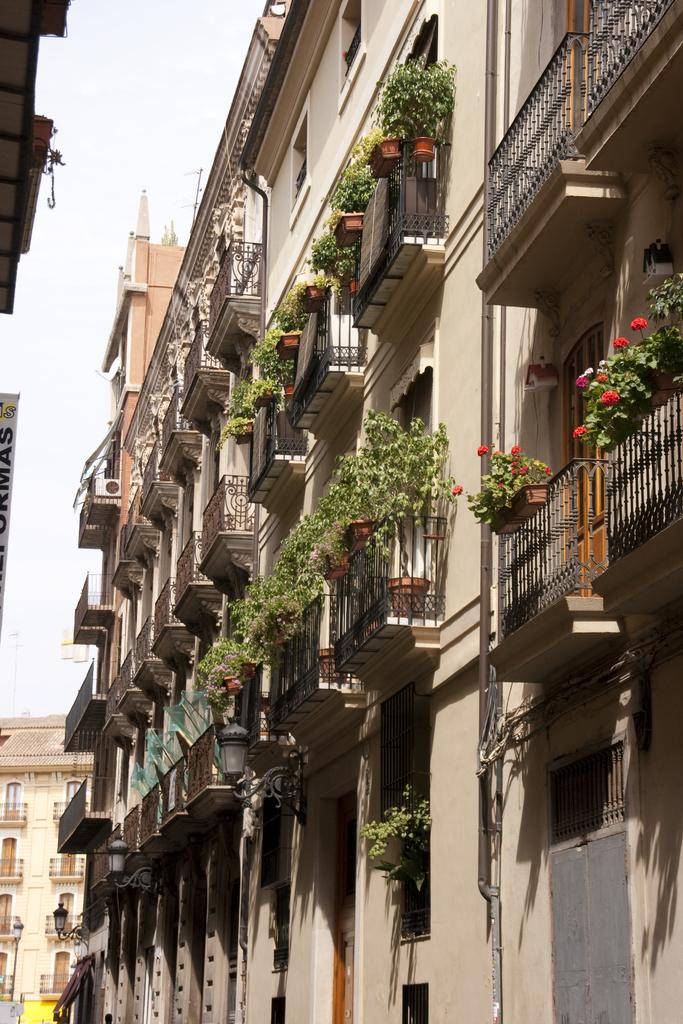What type of structures can be seen in the image? There are buildings in the image. What feature is present near the buildings? Railings are present in the image. What type of vegetation is visible in the image? House plants and flowers are visible in the image. What can be seen illuminating the area in the image? Lights are visible in the image. What is visible in the background of the image? The sky is visible in the background of the image. What word is being spelled out by the lights in the image? There is no word being spelled out by the lights in the image; they are simply illuminating the area. What type of work is being done by the flowers in the image? The flowers are not performing any work in the image; they are simply plants. 